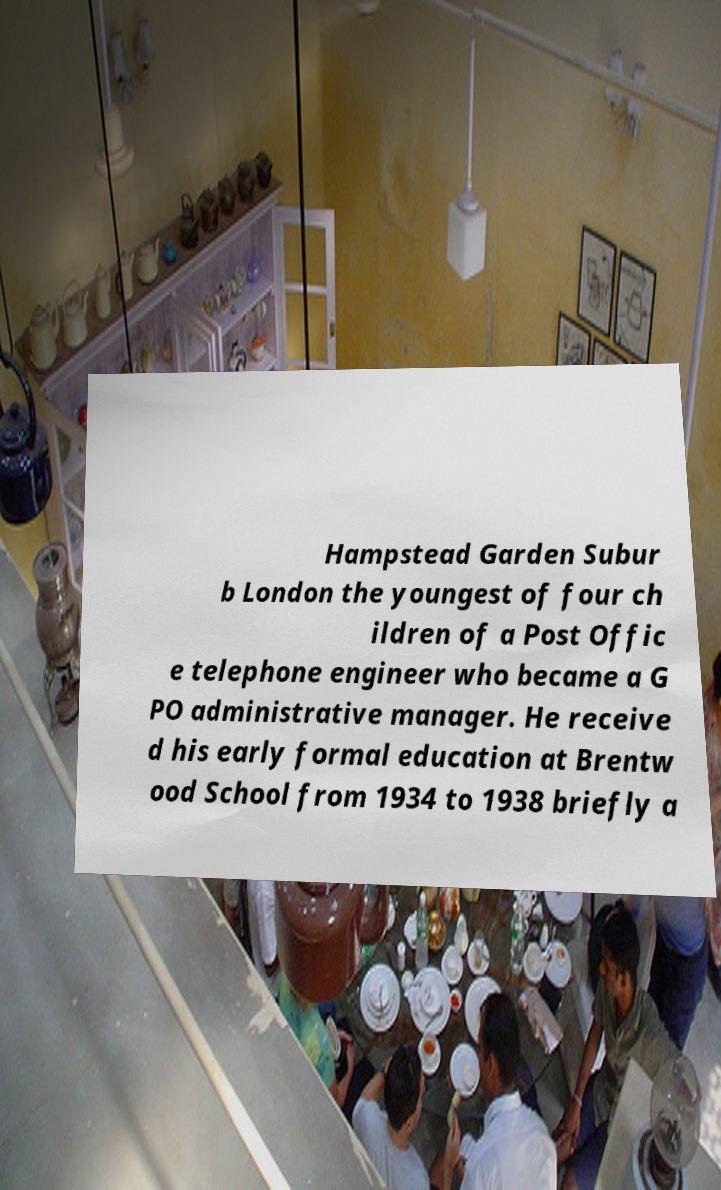There's text embedded in this image that I need extracted. Can you transcribe it verbatim? Hampstead Garden Subur b London the youngest of four ch ildren of a Post Offic e telephone engineer who became a G PO administrative manager. He receive d his early formal education at Brentw ood School from 1934 to 1938 briefly a 